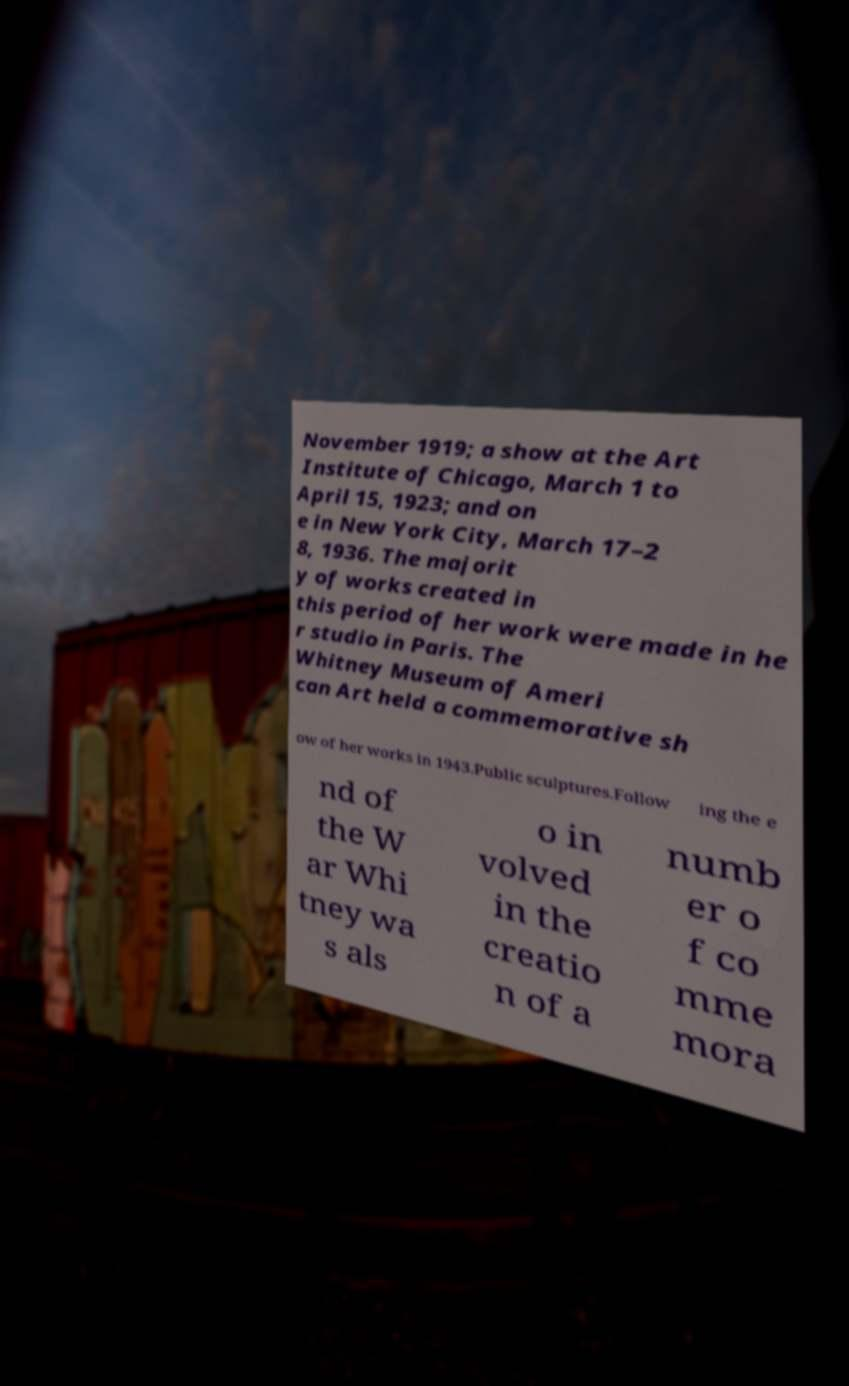What messages or text are displayed in this image? I need them in a readable, typed format. November 1919; a show at the Art Institute of Chicago, March 1 to April 15, 1923; and on e in New York City, March 17–2 8, 1936. The majorit y of works created in this period of her work were made in he r studio in Paris. The Whitney Museum of Ameri can Art held a commemorative sh ow of her works in 1943.Public sculptures.Follow ing the e nd of the W ar Whi tney wa s als o in volved in the creatio n of a numb er o f co mme mora 